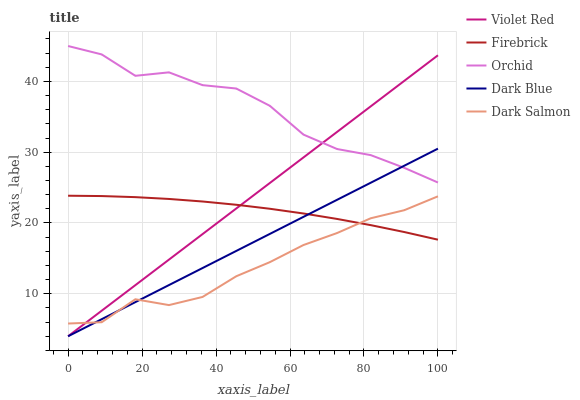Does Dark Salmon have the minimum area under the curve?
Answer yes or no. Yes. Does Orchid have the maximum area under the curve?
Answer yes or no. Yes. Does Violet Red have the minimum area under the curve?
Answer yes or no. No. Does Violet Red have the maximum area under the curve?
Answer yes or no. No. Is Violet Red the smoothest?
Answer yes or no. Yes. Is Orchid the roughest?
Answer yes or no. Yes. Is Dark Salmon the smoothest?
Answer yes or no. No. Is Dark Salmon the roughest?
Answer yes or no. No. Does Dark Blue have the lowest value?
Answer yes or no. Yes. Does Dark Salmon have the lowest value?
Answer yes or no. No. Does Orchid have the highest value?
Answer yes or no. Yes. Does Violet Red have the highest value?
Answer yes or no. No. Is Dark Salmon less than Orchid?
Answer yes or no. Yes. Is Orchid greater than Firebrick?
Answer yes or no. Yes. Does Dark Blue intersect Violet Red?
Answer yes or no. Yes. Is Dark Blue less than Violet Red?
Answer yes or no. No. Is Dark Blue greater than Violet Red?
Answer yes or no. No. Does Dark Salmon intersect Orchid?
Answer yes or no. No. 